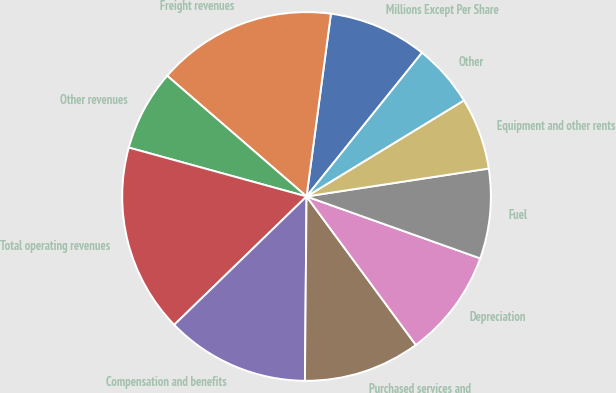<chart> <loc_0><loc_0><loc_500><loc_500><pie_chart><fcel>Millions Except Per Share<fcel>Freight revenues<fcel>Other revenues<fcel>Total operating revenues<fcel>Compensation and benefits<fcel>Purchased services and<fcel>Depreciation<fcel>Fuel<fcel>Equipment and other rents<fcel>Other<nl><fcel>8.66%<fcel>15.75%<fcel>7.09%<fcel>16.53%<fcel>12.6%<fcel>10.24%<fcel>9.45%<fcel>7.87%<fcel>6.3%<fcel>5.51%<nl></chart> 